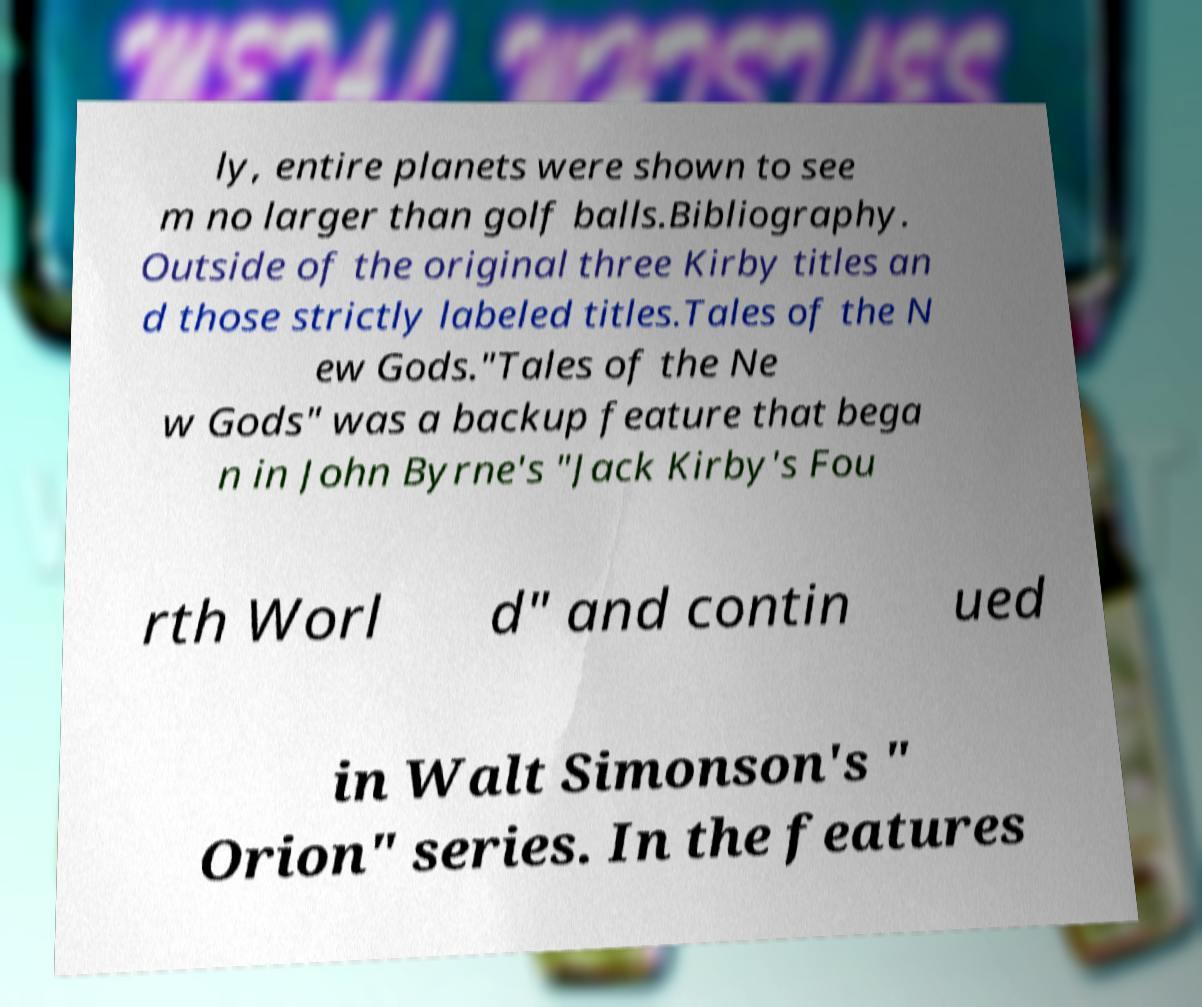What messages or text are displayed in this image? I need them in a readable, typed format. ly, entire planets were shown to see m no larger than golf balls.Bibliography. Outside of the original three Kirby titles an d those strictly labeled titles.Tales of the N ew Gods."Tales of the Ne w Gods" was a backup feature that bega n in John Byrne's "Jack Kirby's Fou rth Worl d" and contin ued in Walt Simonson's " Orion" series. In the features 